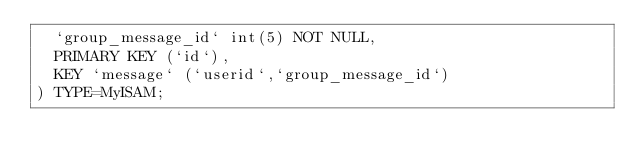<code> <loc_0><loc_0><loc_500><loc_500><_SQL_>  `group_message_id` int(5) NOT NULL,
  PRIMARY KEY (`id`),
  KEY `message` (`userid`,`group_message_id`)
) TYPE=MyISAM;</code> 